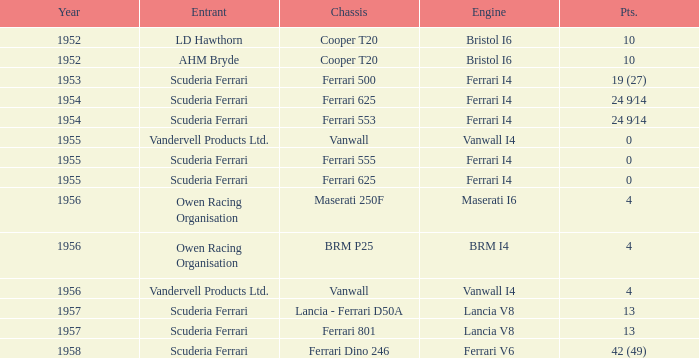Write the full table. {'header': ['Year', 'Entrant', 'Chassis', 'Engine', 'Pts.'], 'rows': [['1952', 'LD Hawthorn', 'Cooper T20', 'Bristol I6', '10'], ['1952', 'AHM Bryde', 'Cooper T20', 'Bristol I6', '10'], ['1953', 'Scuderia Ferrari', 'Ferrari 500', 'Ferrari I4', '19 (27)'], ['1954', 'Scuderia Ferrari', 'Ferrari 625', 'Ferrari I4', '24 9⁄14'], ['1954', 'Scuderia Ferrari', 'Ferrari 553', 'Ferrari I4', '24 9⁄14'], ['1955', 'Vandervell Products Ltd.', 'Vanwall', 'Vanwall I4', '0'], ['1955', 'Scuderia Ferrari', 'Ferrari 555', 'Ferrari I4', '0'], ['1955', 'Scuderia Ferrari', 'Ferrari 625', 'Ferrari I4', '0'], ['1956', 'Owen Racing Organisation', 'Maserati 250F', 'Maserati I6', '4'], ['1956', 'Owen Racing Organisation', 'BRM P25', 'BRM I4', '4'], ['1956', 'Vandervell Products Ltd.', 'Vanwall', 'Vanwall I4', '4'], ['1957', 'Scuderia Ferrari', 'Lancia - Ferrari D50A', 'Lancia V8', '13'], ['1957', 'Scuderia Ferrari', 'Ferrari 801', 'Lancia V8', '13'], ['1958', 'Scuderia Ferrari', 'Ferrari Dino 246', 'Ferrari V6', '42 (49)']]} Who is the entrant when the year is less than 1953? LD Hawthorn, AHM Bryde. 